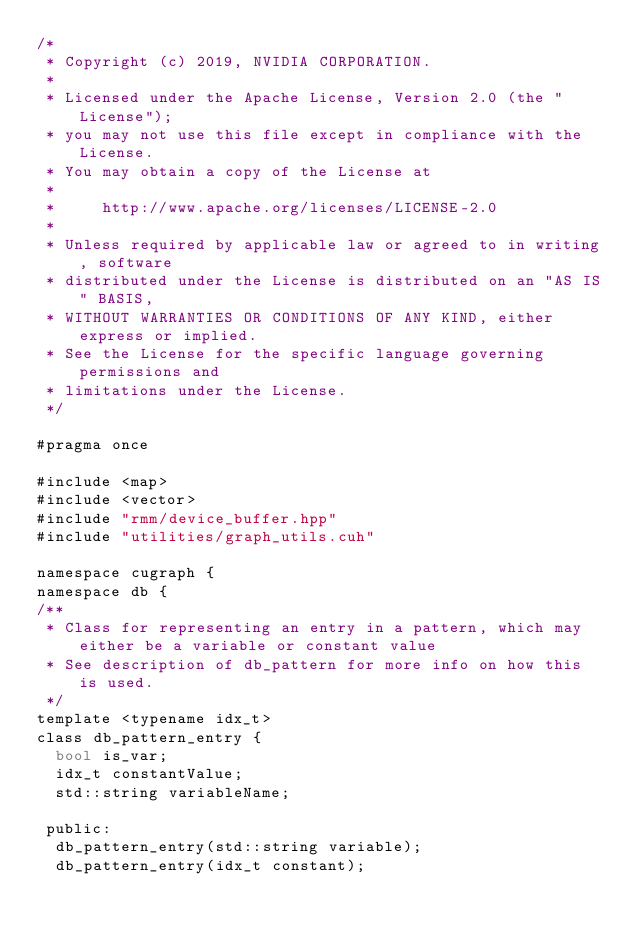<code> <loc_0><loc_0><loc_500><loc_500><_Cuda_>/*
 * Copyright (c) 2019, NVIDIA CORPORATION.
 *
 * Licensed under the Apache License, Version 2.0 (the "License");
 * you may not use this file except in compliance with the License.
 * You may obtain a copy of the License at
 *
 *     http://www.apache.org/licenses/LICENSE-2.0
 *
 * Unless required by applicable law or agreed to in writing, software
 * distributed under the License is distributed on an "AS IS" BASIS,
 * WITHOUT WARRANTIES OR CONDITIONS OF ANY KIND, either express or implied.
 * See the License for the specific language governing permissions and
 * limitations under the License.
 */

#pragma once

#include <map>
#include <vector>
#include "rmm/device_buffer.hpp"
#include "utilities/graph_utils.cuh"

namespace cugraph {
namespace db {
/**
 * Class for representing an entry in a pattern, which may either be a variable or constant value
 * See description of db_pattern for more info on how this is used.
 */
template <typename idx_t>
class db_pattern_entry {
  bool is_var;
  idx_t constantValue;
  std::string variableName;

 public:
  db_pattern_entry(std::string variable);
  db_pattern_entry(idx_t constant);</code> 